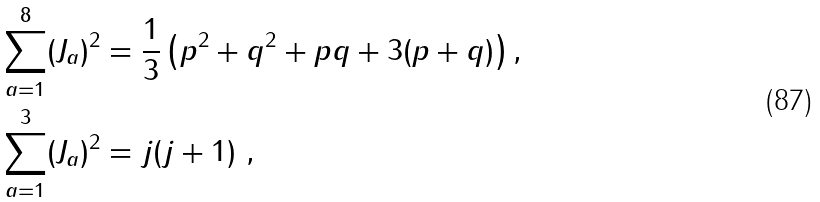Convert formula to latex. <formula><loc_0><loc_0><loc_500><loc_500>\sum _ { a = 1 } ^ { 8 } ( J _ { a } ) ^ { 2 } & = \frac { 1 } { 3 } \left ( p ^ { 2 } + q ^ { 2 } + p q + 3 ( p + q ) \right ) , \\ \sum _ { a = 1 } ^ { 3 } ( J _ { a } ) ^ { 2 } & = j ( j + 1 ) \ ,</formula> 